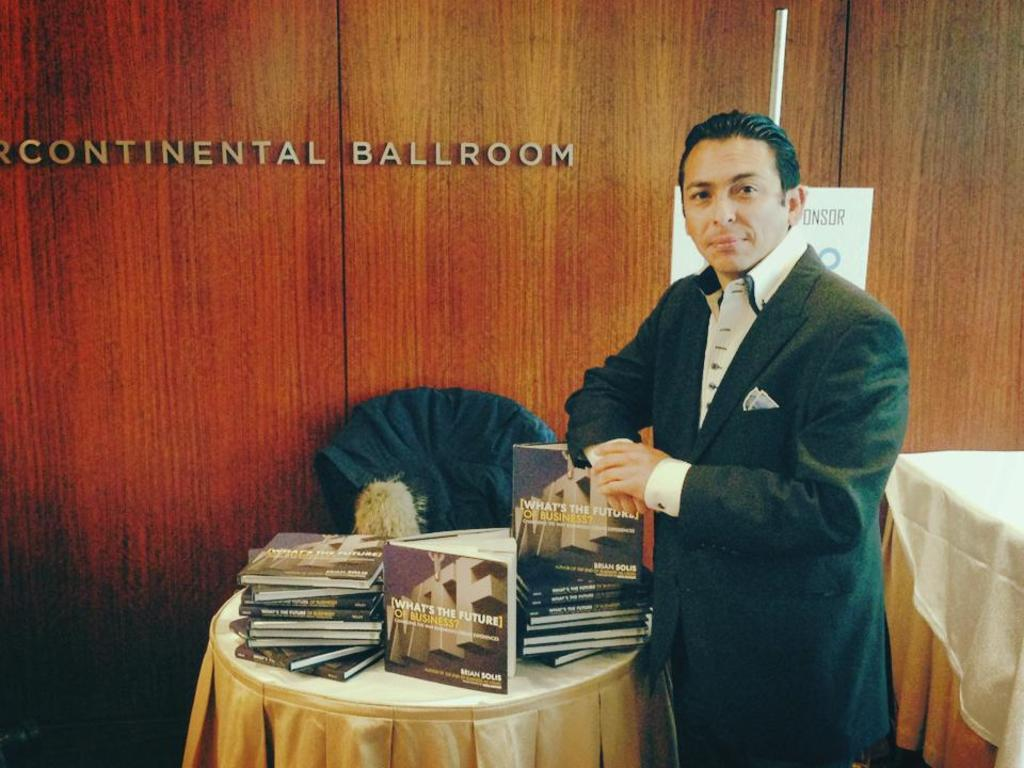<image>
Relay a brief, clear account of the picture shown. A man is standing next to a book in front of a door that reads Continental Ballroom. 